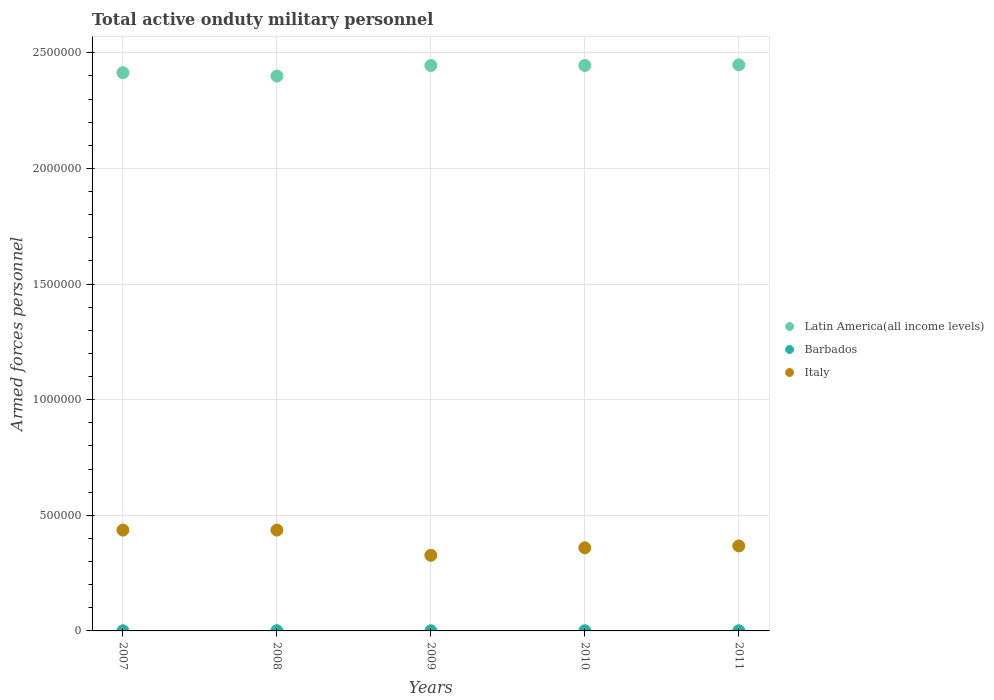How many different coloured dotlines are there?
Give a very brief answer. 3. Across all years, what is the maximum number of armed forces personnel in Italy?
Provide a succinct answer. 4.36e+05. Across all years, what is the minimum number of armed forces personnel in Barbados?
Offer a terse response. 610. What is the total number of armed forces personnel in Italy in the graph?
Give a very brief answer. 1.93e+06. What is the difference between the number of armed forces personnel in Italy in 2007 and that in 2010?
Offer a terse response. 7.66e+04. What is the difference between the number of armed forces personnel in Italy in 2011 and the number of armed forces personnel in Latin America(all income levels) in 2007?
Provide a succinct answer. -2.05e+06. What is the average number of armed forces personnel in Italy per year?
Offer a terse response. 3.85e+05. In the year 2008, what is the difference between the number of armed forces personnel in Barbados and number of armed forces personnel in Latin America(all income levels)?
Your answer should be very brief. -2.40e+06. In how many years, is the number of armed forces personnel in Latin America(all income levels) greater than 300000?
Provide a succinct answer. 5. Is the number of armed forces personnel in Italy in 2008 less than that in 2010?
Keep it short and to the point. No. What is the difference between the highest and the second highest number of armed forces personnel in Latin America(all income levels)?
Make the answer very short. 2821. What is the difference between the highest and the lowest number of armed forces personnel in Barbados?
Your answer should be very brief. 390. Is the sum of the number of armed forces personnel in Italy in 2008 and 2010 greater than the maximum number of armed forces personnel in Barbados across all years?
Keep it short and to the point. Yes. Does the number of armed forces personnel in Barbados monotonically increase over the years?
Provide a short and direct response. No. How many dotlines are there?
Your answer should be compact. 3. What is the difference between two consecutive major ticks on the Y-axis?
Your answer should be compact. 5.00e+05. Does the graph contain grids?
Provide a succinct answer. Yes. Where does the legend appear in the graph?
Ensure brevity in your answer.  Center right. How are the legend labels stacked?
Offer a terse response. Vertical. What is the title of the graph?
Provide a succinct answer. Total active onduty military personnel. What is the label or title of the X-axis?
Offer a very short reply. Years. What is the label or title of the Y-axis?
Your answer should be compact. Armed forces personnel. What is the Armed forces personnel of Latin America(all income levels) in 2007?
Your response must be concise. 2.41e+06. What is the Armed forces personnel of Barbados in 2007?
Make the answer very short. 610. What is the Armed forces personnel of Italy in 2007?
Provide a short and direct response. 4.36e+05. What is the Armed forces personnel in Latin America(all income levels) in 2008?
Your answer should be compact. 2.40e+06. What is the Armed forces personnel in Barbados in 2008?
Your answer should be compact. 1000. What is the Armed forces personnel in Italy in 2008?
Your answer should be compact. 4.36e+05. What is the Armed forces personnel in Latin America(all income levels) in 2009?
Provide a succinct answer. 2.44e+06. What is the Armed forces personnel in Barbados in 2009?
Your answer should be very brief. 610. What is the Armed forces personnel of Italy in 2009?
Offer a terse response. 3.27e+05. What is the Armed forces personnel of Latin America(all income levels) in 2010?
Give a very brief answer. 2.44e+06. What is the Armed forces personnel in Barbados in 2010?
Your response must be concise. 610. What is the Armed forces personnel of Italy in 2010?
Make the answer very short. 3.59e+05. What is the Armed forces personnel of Latin America(all income levels) in 2011?
Provide a succinct answer. 2.45e+06. What is the Armed forces personnel in Barbados in 2011?
Provide a succinct answer. 610. What is the Armed forces personnel of Italy in 2011?
Provide a succinct answer. 3.68e+05. Across all years, what is the maximum Armed forces personnel in Latin America(all income levels)?
Keep it short and to the point. 2.45e+06. Across all years, what is the maximum Armed forces personnel of Barbados?
Offer a terse response. 1000. Across all years, what is the maximum Armed forces personnel in Italy?
Give a very brief answer. 4.36e+05. Across all years, what is the minimum Armed forces personnel in Latin America(all income levels)?
Your answer should be very brief. 2.40e+06. Across all years, what is the minimum Armed forces personnel of Barbados?
Offer a terse response. 610. Across all years, what is the minimum Armed forces personnel in Italy?
Make the answer very short. 3.27e+05. What is the total Armed forces personnel in Latin America(all income levels) in the graph?
Your answer should be compact. 1.22e+07. What is the total Armed forces personnel of Barbados in the graph?
Make the answer very short. 3440. What is the total Armed forces personnel of Italy in the graph?
Offer a terse response. 1.93e+06. What is the difference between the Armed forces personnel of Latin America(all income levels) in 2007 and that in 2008?
Keep it short and to the point. 1.46e+04. What is the difference between the Armed forces personnel in Barbados in 2007 and that in 2008?
Offer a terse response. -390. What is the difference between the Armed forces personnel in Italy in 2007 and that in 2008?
Provide a short and direct response. 0. What is the difference between the Armed forces personnel in Latin America(all income levels) in 2007 and that in 2009?
Offer a terse response. -3.08e+04. What is the difference between the Armed forces personnel in Italy in 2007 and that in 2009?
Your answer should be very brief. 1.09e+05. What is the difference between the Armed forces personnel in Latin America(all income levels) in 2007 and that in 2010?
Offer a terse response. -3.08e+04. What is the difference between the Armed forces personnel of Italy in 2007 and that in 2010?
Offer a terse response. 7.66e+04. What is the difference between the Armed forces personnel in Latin America(all income levels) in 2007 and that in 2011?
Make the answer very short. -3.37e+04. What is the difference between the Armed forces personnel of Italy in 2007 and that in 2011?
Offer a terse response. 6.84e+04. What is the difference between the Armed forces personnel of Latin America(all income levels) in 2008 and that in 2009?
Your answer should be compact. -4.55e+04. What is the difference between the Armed forces personnel of Barbados in 2008 and that in 2009?
Your response must be concise. 390. What is the difference between the Armed forces personnel in Italy in 2008 and that in 2009?
Offer a very short reply. 1.09e+05. What is the difference between the Armed forces personnel in Latin America(all income levels) in 2008 and that in 2010?
Your response must be concise. -4.55e+04. What is the difference between the Armed forces personnel of Barbados in 2008 and that in 2010?
Provide a succinct answer. 390. What is the difference between the Armed forces personnel of Italy in 2008 and that in 2010?
Offer a very short reply. 7.66e+04. What is the difference between the Armed forces personnel of Latin America(all income levels) in 2008 and that in 2011?
Ensure brevity in your answer.  -4.83e+04. What is the difference between the Armed forces personnel of Barbados in 2008 and that in 2011?
Give a very brief answer. 390. What is the difference between the Armed forces personnel in Italy in 2008 and that in 2011?
Give a very brief answer. 6.84e+04. What is the difference between the Armed forces personnel of Italy in 2009 and that in 2010?
Provide a short and direct response. -3.24e+04. What is the difference between the Armed forces personnel of Latin America(all income levels) in 2009 and that in 2011?
Offer a very short reply. -2821. What is the difference between the Armed forces personnel in Barbados in 2009 and that in 2011?
Provide a short and direct response. 0. What is the difference between the Armed forces personnel of Italy in 2009 and that in 2011?
Make the answer very short. -4.06e+04. What is the difference between the Armed forces personnel in Latin America(all income levels) in 2010 and that in 2011?
Make the answer very short. -2821. What is the difference between the Armed forces personnel in Barbados in 2010 and that in 2011?
Offer a terse response. 0. What is the difference between the Armed forces personnel of Italy in 2010 and that in 2011?
Your answer should be compact. -8172. What is the difference between the Armed forces personnel of Latin America(all income levels) in 2007 and the Armed forces personnel of Barbados in 2008?
Offer a very short reply. 2.41e+06. What is the difference between the Armed forces personnel in Latin America(all income levels) in 2007 and the Armed forces personnel in Italy in 2008?
Your answer should be very brief. 1.98e+06. What is the difference between the Armed forces personnel in Barbados in 2007 and the Armed forces personnel in Italy in 2008?
Offer a terse response. -4.35e+05. What is the difference between the Armed forces personnel in Latin America(all income levels) in 2007 and the Armed forces personnel in Barbados in 2009?
Ensure brevity in your answer.  2.41e+06. What is the difference between the Armed forces personnel of Latin America(all income levels) in 2007 and the Armed forces personnel of Italy in 2009?
Give a very brief answer. 2.09e+06. What is the difference between the Armed forces personnel of Barbados in 2007 and the Armed forces personnel of Italy in 2009?
Your answer should be compact. -3.26e+05. What is the difference between the Armed forces personnel in Latin America(all income levels) in 2007 and the Armed forces personnel in Barbados in 2010?
Give a very brief answer. 2.41e+06. What is the difference between the Armed forces personnel in Latin America(all income levels) in 2007 and the Armed forces personnel in Italy in 2010?
Provide a succinct answer. 2.05e+06. What is the difference between the Armed forces personnel of Barbados in 2007 and the Armed forces personnel of Italy in 2010?
Provide a short and direct response. -3.59e+05. What is the difference between the Armed forces personnel in Latin America(all income levels) in 2007 and the Armed forces personnel in Barbados in 2011?
Keep it short and to the point. 2.41e+06. What is the difference between the Armed forces personnel of Latin America(all income levels) in 2007 and the Armed forces personnel of Italy in 2011?
Make the answer very short. 2.05e+06. What is the difference between the Armed forces personnel in Barbados in 2007 and the Armed forces personnel in Italy in 2011?
Ensure brevity in your answer.  -3.67e+05. What is the difference between the Armed forces personnel of Latin America(all income levels) in 2008 and the Armed forces personnel of Barbados in 2009?
Your answer should be compact. 2.40e+06. What is the difference between the Armed forces personnel of Latin America(all income levels) in 2008 and the Armed forces personnel of Italy in 2009?
Provide a short and direct response. 2.07e+06. What is the difference between the Armed forces personnel of Barbados in 2008 and the Armed forces personnel of Italy in 2009?
Ensure brevity in your answer.  -3.26e+05. What is the difference between the Armed forces personnel of Latin America(all income levels) in 2008 and the Armed forces personnel of Barbados in 2010?
Make the answer very short. 2.40e+06. What is the difference between the Armed forces personnel of Latin America(all income levels) in 2008 and the Armed forces personnel of Italy in 2010?
Provide a succinct answer. 2.04e+06. What is the difference between the Armed forces personnel of Barbados in 2008 and the Armed forces personnel of Italy in 2010?
Your answer should be very brief. -3.58e+05. What is the difference between the Armed forces personnel in Latin America(all income levels) in 2008 and the Armed forces personnel in Barbados in 2011?
Offer a terse response. 2.40e+06. What is the difference between the Armed forces personnel of Latin America(all income levels) in 2008 and the Armed forces personnel of Italy in 2011?
Keep it short and to the point. 2.03e+06. What is the difference between the Armed forces personnel of Barbados in 2008 and the Armed forces personnel of Italy in 2011?
Make the answer very short. -3.67e+05. What is the difference between the Armed forces personnel in Latin America(all income levels) in 2009 and the Armed forces personnel in Barbados in 2010?
Provide a short and direct response. 2.44e+06. What is the difference between the Armed forces personnel of Latin America(all income levels) in 2009 and the Armed forces personnel of Italy in 2010?
Provide a succinct answer. 2.09e+06. What is the difference between the Armed forces personnel of Barbados in 2009 and the Armed forces personnel of Italy in 2010?
Your answer should be compact. -3.59e+05. What is the difference between the Armed forces personnel of Latin America(all income levels) in 2009 and the Armed forces personnel of Barbados in 2011?
Provide a short and direct response. 2.44e+06. What is the difference between the Armed forces personnel of Latin America(all income levels) in 2009 and the Armed forces personnel of Italy in 2011?
Offer a terse response. 2.08e+06. What is the difference between the Armed forces personnel in Barbados in 2009 and the Armed forces personnel in Italy in 2011?
Provide a short and direct response. -3.67e+05. What is the difference between the Armed forces personnel in Latin America(all income levels) in 2010 and the Armed forces personnel in Barbados in 2011?
Your response must be concise. 2.44e+06. What is the difference between the Armed forces personnel in Latin America(all income levels) in 2010 and the Armed forces personnel in Italy in 2011?
Provide a succinct answer. 2.08e+06. What is the difference between the Armed forces personnel of Barbados in 2010 and the Armed forces personnel of Italy in 2011?
Keep it short and to the point. -3.67e+05. What is the average Armed forces personnel in Latin America(all income levels) per year?
Ensure brevity in your answer.  2.43e+06. What is the average Armed forces personnel of Barbados per year?
Your answer should be compact. 688. What is the average Armed forces personnel in Italy per year?
Make the answer very short. 3.85e+05. In the year 2007, what is the difference between the Armed forces personnel in Latin America(all income levels) and Armed forces personnel in Barbados?
Provide a succinct answer. 2.41e+06. In the year 2007, what is the difference between the Armed forces personnel of Latin America(all income levels) and Armed forces personnel of Italy?
Your answer should be very brief. 1.98e+06. In the year 2007, what is the difference between the Armed forces personnel in Barbados and Armed forces personnel in Italy?
Keep it short and to the point. -4.35e+05. In the year 2008, what is the difference between the Armed forces personnel in Latin America(all income levels) and Armed forces personnel in Barbados?
Make the answer very short. 2.40e+06. In the year 2008, what is the difference between the Armed forces personnel of Latin America(all income levels) and Armed forces personnel of Italy?
Keep it short and to the point. 1.96e+06. In the year 2008, what is the difference between the Armed forces personnel in Barbados and Armed forces personnel in Italy?
Offer a terse response. -4.35e+05. In the year 2009, what is the difference between the Armed forces personnel of Latin America(all income levels) and Armed forces personnel of Barbados?
Offer a very short reply. 2.44e+06. In the year 2009, what is the difference between the Armed forces personnel of Latin America(all income levels) and Armed forces personnel of Italy?
Keep it short and to the point. 2.12e+06. In the year 2009, what is the difference between the Armed forces personnel of Barbados and Armed forces personnel of Italy?
Make the answer very short. -3.26e+05. In the year 2010, what is the difference between the Armed forces personnel of Latin America(all income levels) and Armed forces personnel of Barbados?
Offer a terse response. 2.44e+06. In the year 2010, what is the difference between the Armed forces personnel of Latin America(all income levels) and Armed forces personnel of Italy?
Give a very brief answer. 2.09e+06. In the year 2010, what is the difference between the Armed forces personnel in Barbados and Armed forces personnel in Italy?
Make the answer very short. -3.59e+05. In the year 2011, what is the difference between the Armed forces personnel in Latin America(all income levels) and Armed forces personnel in Barbados?
Ensure brevity in your answer.  2.45e+06. In the year 2011, what is the difference between the Armed forces personnel of Latin America(all income levels) and Armed forces personnel of Italy?
Give a very brief answer. 2.08e+06. In the year 2011, what is the difference between the Armed forces personnel in Barbados and Armed forces personnel in Italy?
Ensure brevity in your answer.  -3.67e+05. What is the ratio of the Armed forces personnel in Barbados in 2007 to that in 2008?
Keep it short and to the point. 0.61. What is the ratio of the Armed forces personnel in Latin America(all income levels) in 2007 to that in 2009?
Offer a terse response. 0.99. What is the ratio of the Armed forces personnel of Barbados in 2007 to that in 2009?
Give a very brief answer. 1. What is the ratio of the Armed forces personnel of Italy in 2007 to that in 2009?
Provide a short and direct response. 1.33. What is the ratio of the Armed forces personnel of Latin America(all income levels) in 2007 to that in 2010?
Offer a very short reply. 0.99. What is the ratio of the Armed forces personnel in Italy in 2007 to that in 2010?
Keep it short and to the point. 1.21. What is the ratio of the Armed forces personnel of Latin America(all income levels) in 2007 to that in 2011?
Ensure brevity in your answer.  0.99. What is the ratio of the Armed forces personnel in Italy in 2007 to that in 2011?
Offer a very short reply. 1.19. What is the ratio of the Armed forces personnel of Latin America(all income levels) in 2008 to that in 2009?
Make the answer very short. 0.98. What is the ratio of the Armed forces personnel of Barbados in 2008 to that in 2009?
Your answer should be very brief. 1.64. What is the ratio of the Armed forces personnel in Italy in 2008 to that in 2009?
Provide a short and direct response. 1.33. What is the ratio of the Armed forces personnel of Latin America(all income levels) in 2008 to that in 2010?
Provide a short and direct response. 0.98. What is the ratio of the Armed forces personnel of Barbados in 2008 to that in 2010?
Provide a succinct answer. 1.64. What is the ratio of the Armed forces personnel in Italy in 2008 to that in 2010?
Your response must be concise. 1.21. What is the ratio of the Armed forces personnel in Latin America(all income levels) in 2008 to that in 2011?
Your answer should be very brief. 0.98. What is the ratio of the Armed forces personnel in Barbados in 2008 to that in 2011?
Keep it short and to the point. 1.64. What is the ratio of the Armed forces personnel in Italy in 2008 to that in 2011?
Offer a very short reply. 1.19. What is the ratio of the Armed forces personnel in Latin America(all income levels) in 2009 to that in 2010?
Your answer should be compact. 1. What is the ratio of the Armed forces personnel in Italy in 2009 to that in 2010?
Keep it short and to the point. 0.91. What is the ratio of the Armed forces personnel in Latin America(all income levels) in 2009 to that in 2011?
Your response must be concise. 1. What is the ratio of the Armed forces personnel of Italy in 2009 to that in 2011?
Your answer should be compact. 0.89. What is the ratio of the Armed forces personnel of Latin America(all income levels) in 2010 to that in 2011?
Offer a very short reply. 1. What is the ratio of the Armed forces personnel of Barbados in 2010 to that in 2011?
Your response must be concise. 1. What is the ratio of the Armed forces personnel in Italy in 2010 to that in 2011?
Your response must be concise. 0.98. What is the difference between the highest and the second highest Armed forces personnel of Latin America(all income levels)?
Keep it short and to the point. 2821. What is the difference between the highest and the second highest Armed forces personnel in Barbados?
Provide a succinct answer. 390. What is the difference between the highest and the second highest Armed forces personnel of Italy?
Provide a short and direct response. 0. What is the difference between the highest and the lowest Armed forces personnel in Latin America(all income levels)?
Offer a terse response. 4.83e+04. What is the difference between the highest and the lowest Armed forces personnel in Barbados?
Your response must be concise. 390. What is the difference between the highest and the lowest Armed forces personnel in Italy?
Your answer should be compact. 1.09e+05. 